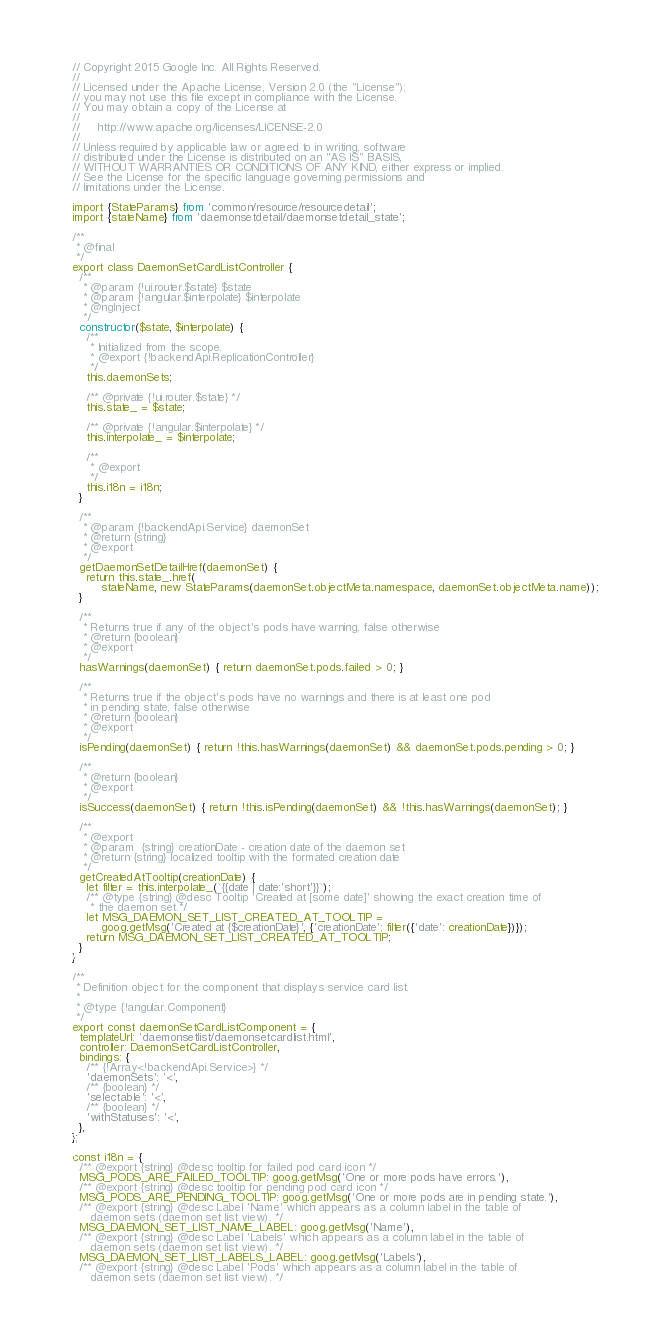<code> <loc_0><loc_0><loc_500><loc_500><_JavaScript_>// Copyright 2015 Google Inc. All Rights Reserved.
//
// Licensed under the Apache License, Version 2.0 (the "License");
// you may not use this file except in compliance with the License.
// You may obtain a copy of the License at
//
//     http://www.apache.org/licenses/LICENSE-2.0
//
// Unless required by applicable law or agreed to in writing, software
// distributed under the License is distributed on an "AS IS" BASIS,
// WITHOUT WARRANTIES OR CONDITIONS OF ANY KIND, either express or implied.
// See the License for the specific language governing permissions and
// limitations under the License.

import {StateParams} from 'common/resource/resourcedetail';
import {stateName} from 'daemonsetdetail/daemonsetdetail_state';

/**
 * @final
 */
export class DaemonSetCardListController {
  /**
   * @param {!ui.router.$state} $state
   * @param {!angular.$interpolate} $interpolate
   * @ngInject
   */
  constructor($state, $interpolate) {
    /**
     * Initialized from the scope.
     * @export {!backendApi.ReplicationController}
     */
    this.daemonSets;

    /** @private {!ui.router.$state} */
    this.state_ = $state;

    /** @private {!angular.$interpolate} */
    this.interpolate_ = $interpolate;

    /**
     * @export
     */
    this.i18n = i18n;
  }

  /**
   * @param {!backendApi.Service} daemonSet
   * @return {string}
   * @export
   */
  getDaemonSetDetailHref(daemonSet) {
    return this.state_.href(
        stateName, new StateParams(daemonSet.objectMeta.namespace, daemonSet.objectMeta.name));
  }

  /**
   * Returns true if any of the object's pods have warning, false otherwise
   * @return {boolean}
   * @export
   */
  hasWarnings(daemonSet) { return daemonSet.pods.failed > 0; }

  /**
   * Returns true if the object's pods have no warnings and there is at least one pod
   * in pending state, false otherwise
   * @return {boolean}
   * @export
   */
  isPending(daemonSet) { return !this.hasWarnings(daemonSet) && daemonSet.pods.pending > 0; }

  /**
   * @return {boolean}
   * @export
   */
  isSuccess(daemonSet) { return !this.isPending(daemonSet) && !this.hasWarnings(daemonSet); }

  /**
   * @export
   * @param  {string} creationDate - creation date of the daemon set
   * @return {string} localized tooltip with the formated creation date
   */
  getCreatedAtTooltip(creationDate) {
    let filter = this.interpolate_(`{{date | date:'short'}}`);
    /** @type {string} @desc Tooltip 'Created at [some date]' showing the exact creation time of
     * the daemon set.*/
    let MSG_DAEMON_SET_LIST_CREATED_AT_TOOLTIP =
        goog.getMsg('Created at {$creationDate}', {'creationDate': filter({'date': creationDate})});
    return MSG_DAEMON_SET_LIST_CREATED_AT_TOOLTIP;
  }
}

/**
 * Definition object for the component that displays service card list.
 *
 * @type {!angular.Component}
 */
export const daemonSetCardListComponent = {
  templateUrl: 'daemonsetlist/daemonsetcardlist.html',
  controller: DaemonSetCardListController,
  bindings: {
    /** {!Array<!backendApi.Service>} */
    'daemonSets': '<',
    /** {boolean} */
    'selectable': '<',
    /** {boolean} */
    'withStatuses': '<',
  },
};

const i18n = {
  /** @export {string} @desc tooltip for failed pod card icon */
  MSG_PODS_ARE_FAILED_TOOLTIP: goog.getMsg('One or more pods have errors.'),
  /** @export {string} @desc tooltip for pending pod card icon */
  MSG_PODS_ARE_PENDING_TOOLTIP: goog.getMsg('One or more pods are in pending state.'),
  /** @export {string} @desc Label 'Name' which appears as a column label in the table of
     daemon sets (daemon set list view). */
  MSG_DAEMON_SET_LIST_NAME_LABEL: goog.getMsg('Name'),
  /** @export {string} @desc Label 'Labels' which appears as a column label in the table of
     daemon sets (daemon set list view). */
  MSG_DAEMON_SET_LIST_LABELS_LABEL: goog.getMsg('Labels'),
  /** @export {string} @desc Label 'Pods' which appears as a column label in the table of
     daemon sets (daemon set list view). */</code> 